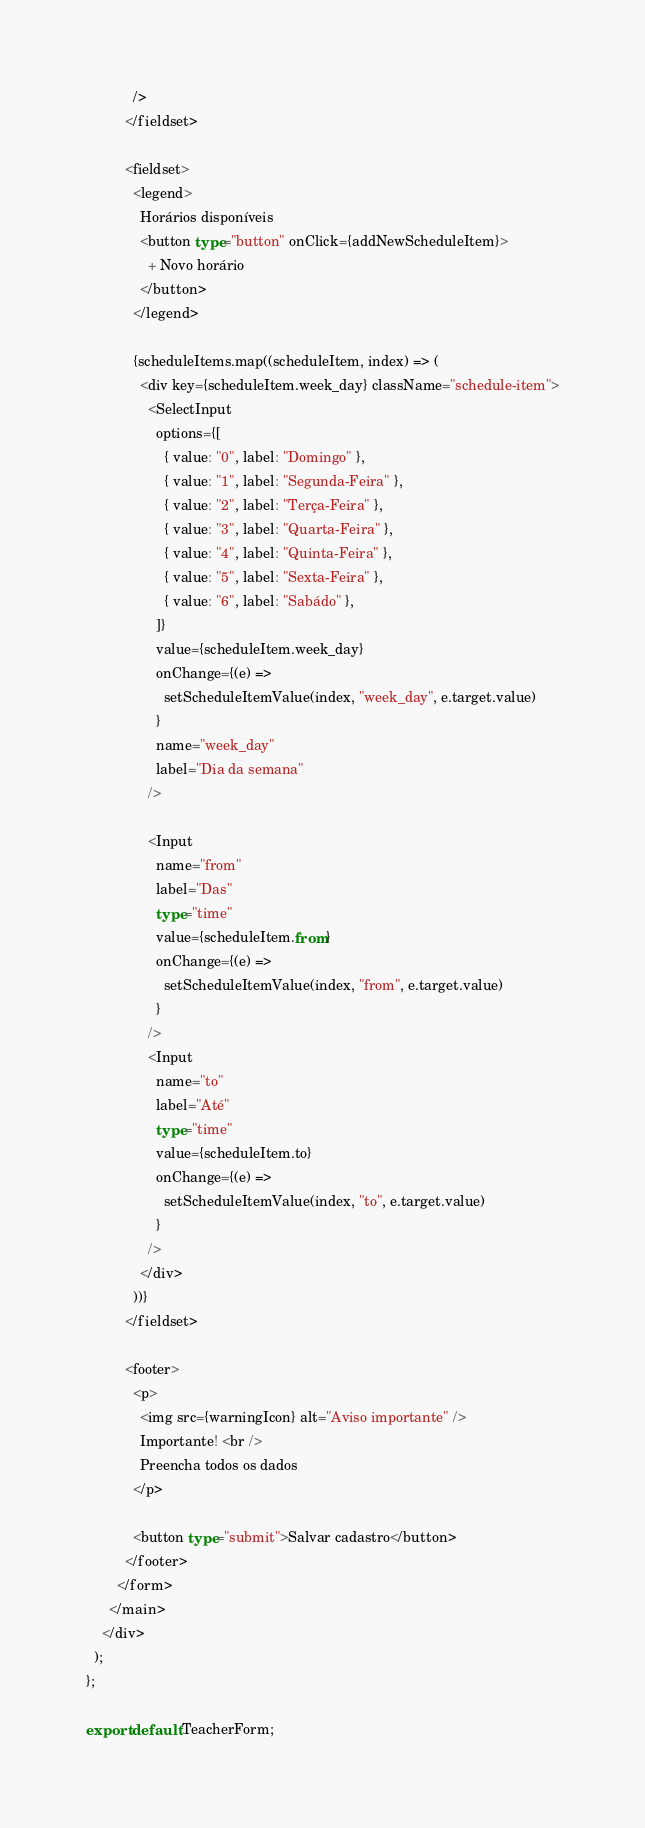Convert code to text. <code><loc_0><loc_0><loc_500><loc_500><_TypeScript_>            />
          </fieldset>

          <fieldset>
            <legend>
              Horários disponíveis
              <button type="button" onClick={addNewScheduleItem}>
                + Novo horário
              </button>
            </legend>

            {scheduleItems.map((scheduleItem, index) => (
              <div key={scheduleItem.week_day} className="schedule-item">
                <SelectInput
                  options={[
                    { value: "0", label: "Domingo" },
                    { value: "1", label: "Segunda-Feira" },
                    { value: "2", label: "Terça-Feira" },
                    { value: "3", label: "Quarta-Feira" },
                    { value: "4", label: "Quinta-Feira" },
                    { value: "5", label: "Sexta-Feira" },
                    { value: "6", label: "Sabádo" },
                  ]}
                  value={scheduleItem.week_day}
                  onChange={(e) =>
                    setScheduleItemValue(index, "week_day", e.target.value)
                  }
                  name="week_day"
                  label="Dia da semana"
                />

                <Input
                  name="from"
                  label="Das"
                  type="time"
                  value={scheduleItem.from}
                  onChange={(e) =>
                    setScheduleItemValue(index, "from", e.target.value)
                  }
                />
                <Input
                  name="to"
                  label="Até"
                  type="time"
                  value={scheduleItem.to}
                  onChange={(e) =>
                    setScheduleItemValue(index, "to", e.target.value)
                  }
                />
              </div>
            ))}
          </fieldset>

          <footer>
            <p>
              <img src={warningIcon} alt="Aviso importante" />
              Importante! <br />
              Preencha todos os dados
            </p>

            <button type="submit">Salvar cadastro</button>
          </footer>
        </form>
      </main>
    </div>
  );
};

export default TeacherForm;
</code> 